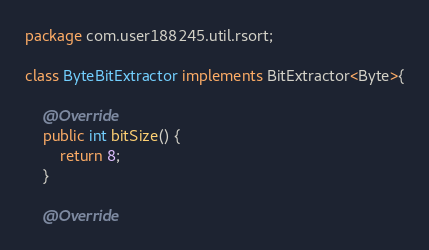<code> <loc_0><loc_0><loc_500><loc_500><_Java_>package com.user188245.util.rsort;

class ByteBitExtractor implements BitExtractor<Byte>{

	@Override
	public int bitSize() {
		return 8;
	}

	@Override</code> 